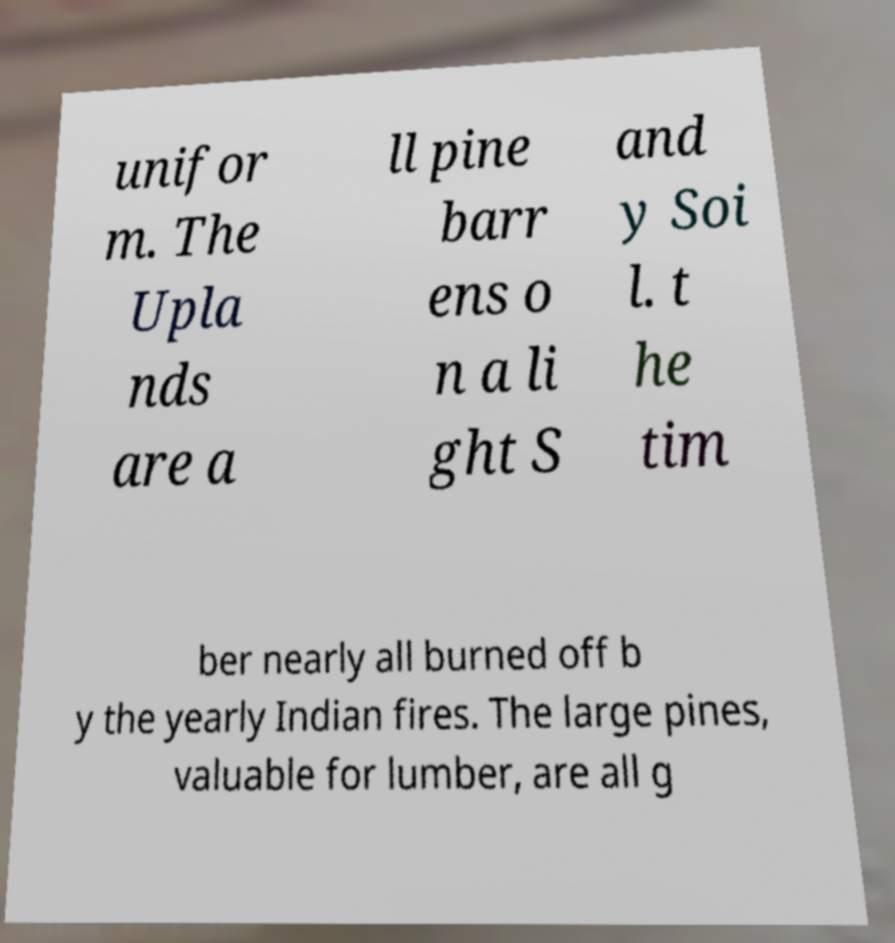Please read and relay the text visible in this image. What does it say? unifor m. The Upla nds are a ll pine barr ens o n a li ght S and y Soi l. t he tim ber nearly all burned off b y the yearly Indian fires. The large pines, valuable for lumber, are all g 